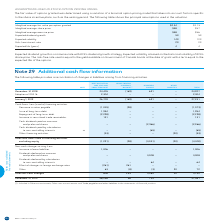According to Bce's financial document, How is the fair value of options granted determined? using a variation of a binomial option pricing model that takes into account factors specific to the share incentive plans, such as the vesting period. The document states: "The fair value of options granted was determined using a variation of a binomial option pricing model that takes into account factors specific to the ..." Also, What is expected volatility based on? the historical volatility of BCE’s share price. The document states: "growth strategy. Expected volatility is based on the historical volatility of BCE’s share price. The risk-free rate used is equal to the yield availab..." Also, Which assumption variables in the table are further elaborated in the text? The document contains multiple relevant values: Expected dividend growth, Expected volatility, Risk-free interest rate. From the document: "Expected dividend growth 5% 5% Risk-free interest rate 2% 2% Expected volatility 14% 12%..." Additionally, In which year is the weighted average share price higher? According to the financial document, 2019. The relevant text states: "2019 2018..." Also, can you calculate: What is the change in the expected volatility in 2019? Based on the calculation: 14%-12%, the result is 2 (percentage). This is based on the information: "Expected volatility 14% 12% Expected volatility 14% 12%..." The key data points involved are: 12, 14. Also, can you calculate: What is the average expected life over 2018 and 2019? To answer this question, I need to perform calculations using the financial data. The calculation is: (4+4)/2, which equals 4. This is based on the information: "eighted average fair value per option granted $2.34 $2.13..." 